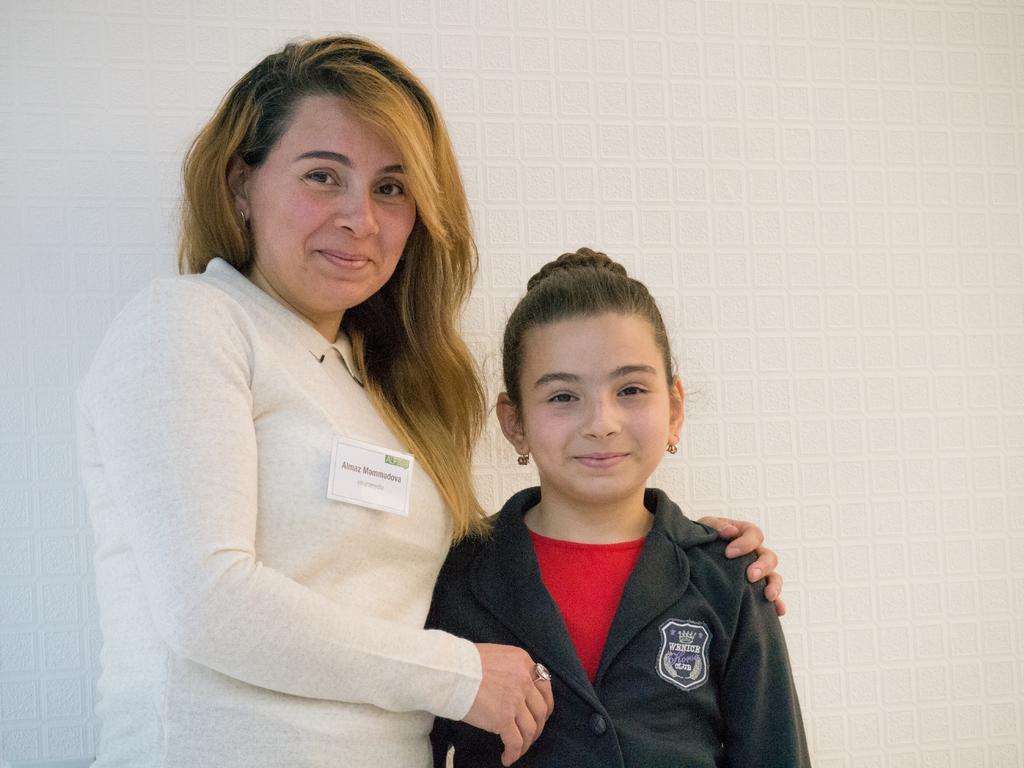Could you give a brief overview of what you see in this image? In this image we can see two persons standing and smiling, in the background we can see the wall. 